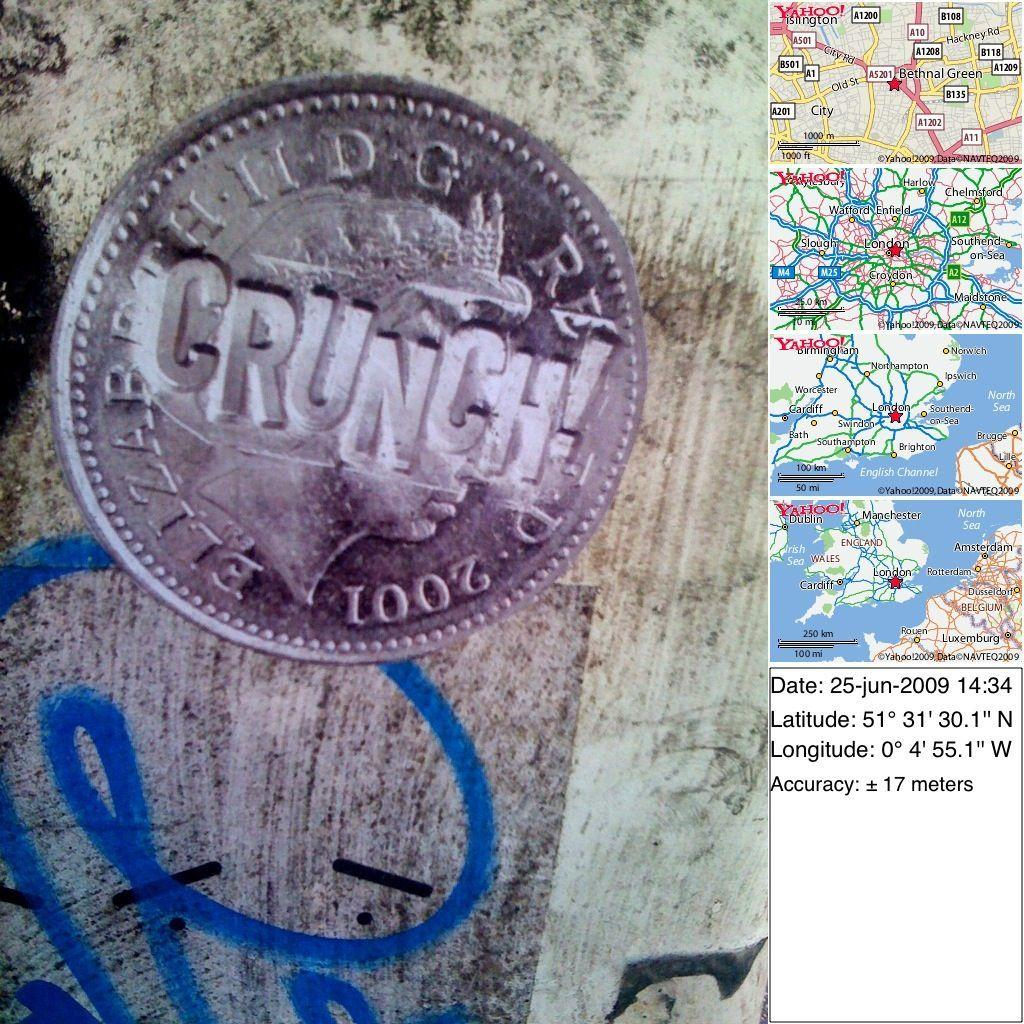<image>
Share a concise interpretation of the image provided. Blizzard Crunch 2001 is stamped onto the face of this odd coin. 